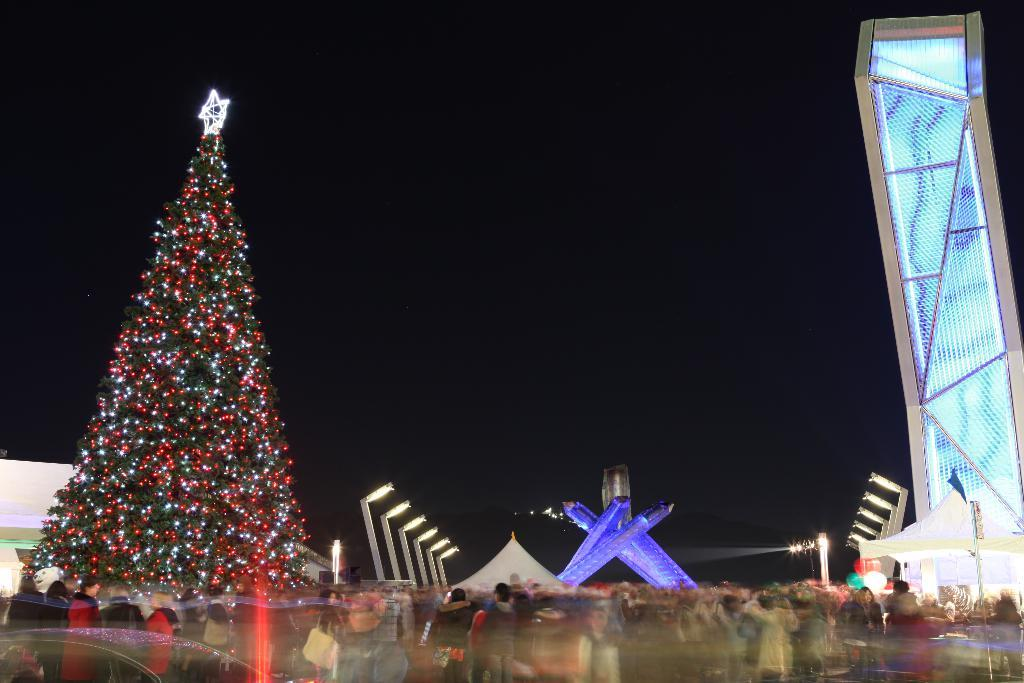What is the main object in the image? There is a Christmas tree in the image. What can be seen on the tree? There are lights on the tree. Are there any people in the image? Yes, there are people beside the tree in the image. What is visible in the background of the image? The sky is visible in the image. Can you tell me how many gallons of oil are being used to power the lights on the tree? There is no information about the type of lights or their power source in the image, so it is impossible to determine the amount of oil being used. What type of digestive system do the people near the tree have? The image does not provide any information about the people's digestive systems, so it cannot be determined. 